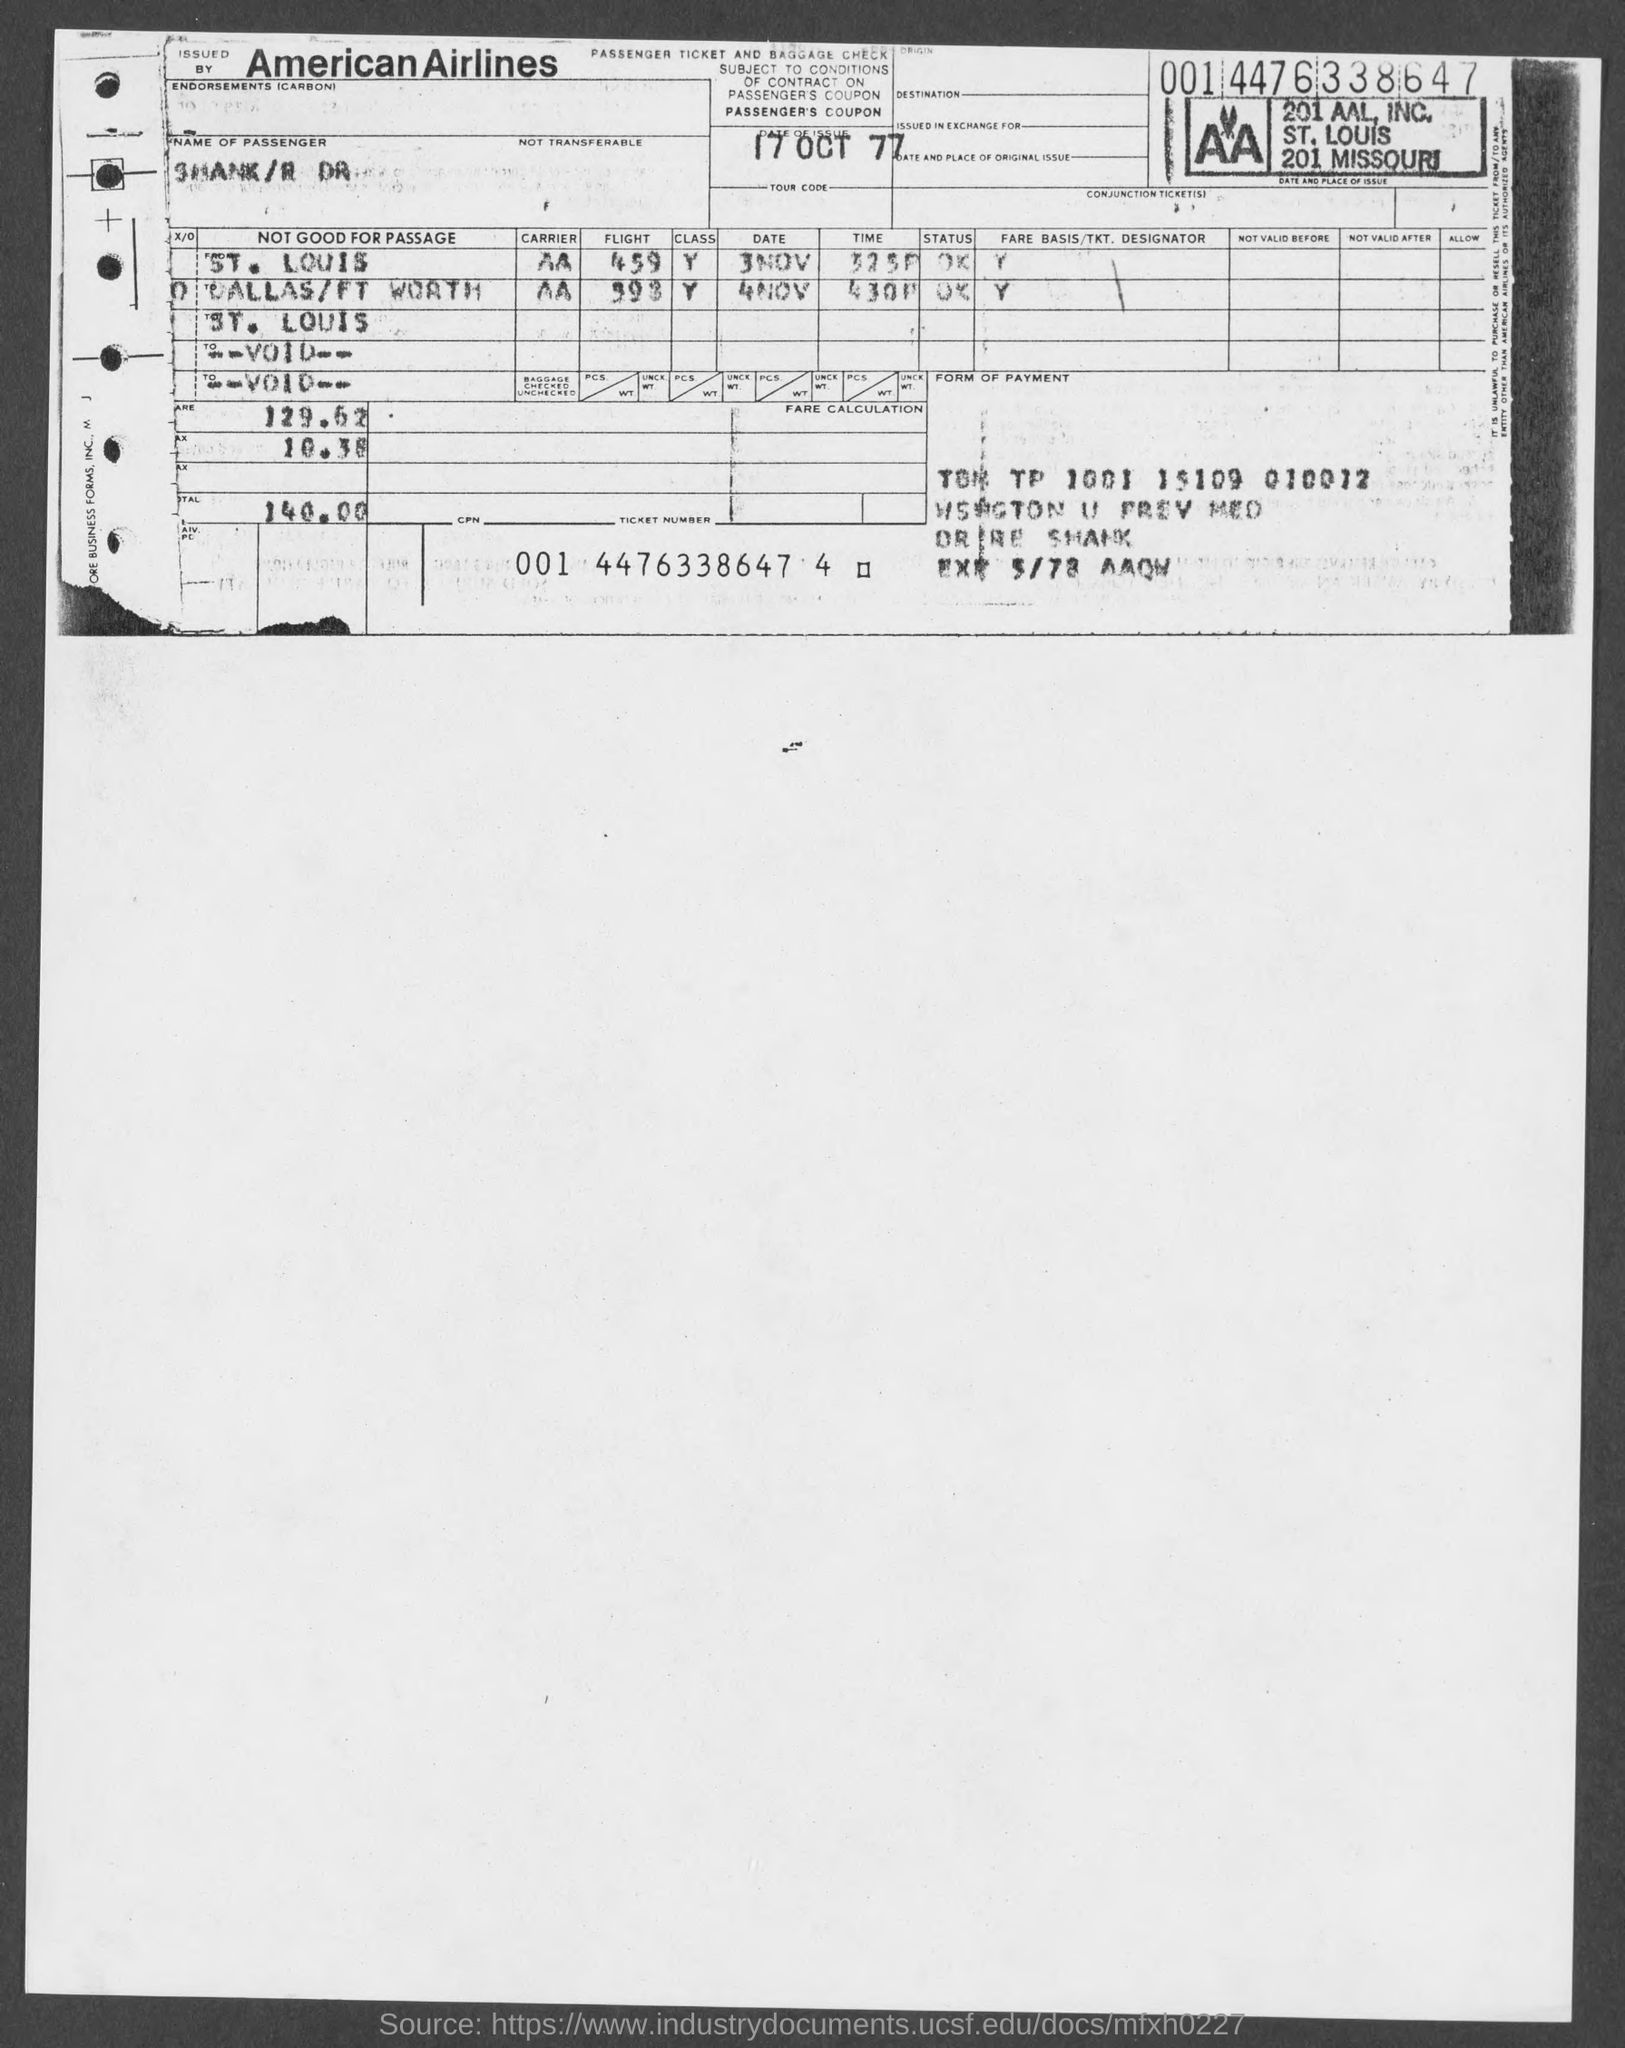Indicate a few pertinent items in this graphic. The date of issue is 17 October 1977. American Airlines provides the ticket for Which Airlines? 